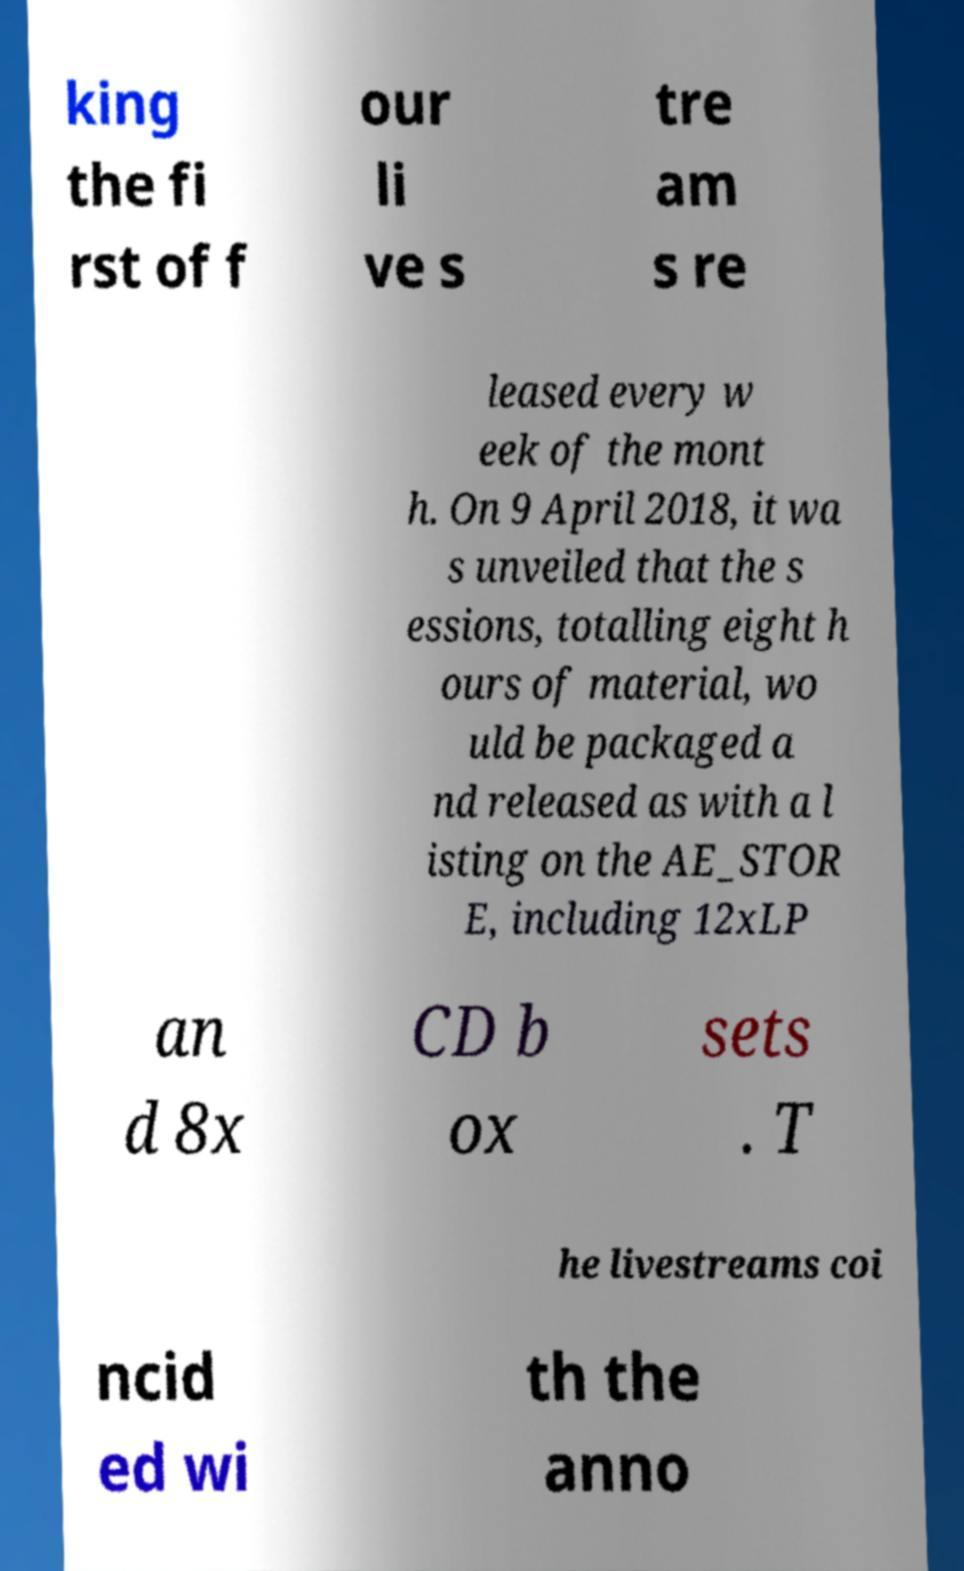There's text embedded in this image that I need extracted. Can you transcribe it verbatim? king the fi rst of f our li ve s tre am s re leased every w eek of the mont h. On 9 April 2018, it wa s unveiled that the s essions, totalling eight h ours of material, wo uld be packaged a nd released as with a l isting on the AE_STOR E, including 12xLP an d 8x CD b ox sets . T he livestreams coi ncid ed wi th the anno 